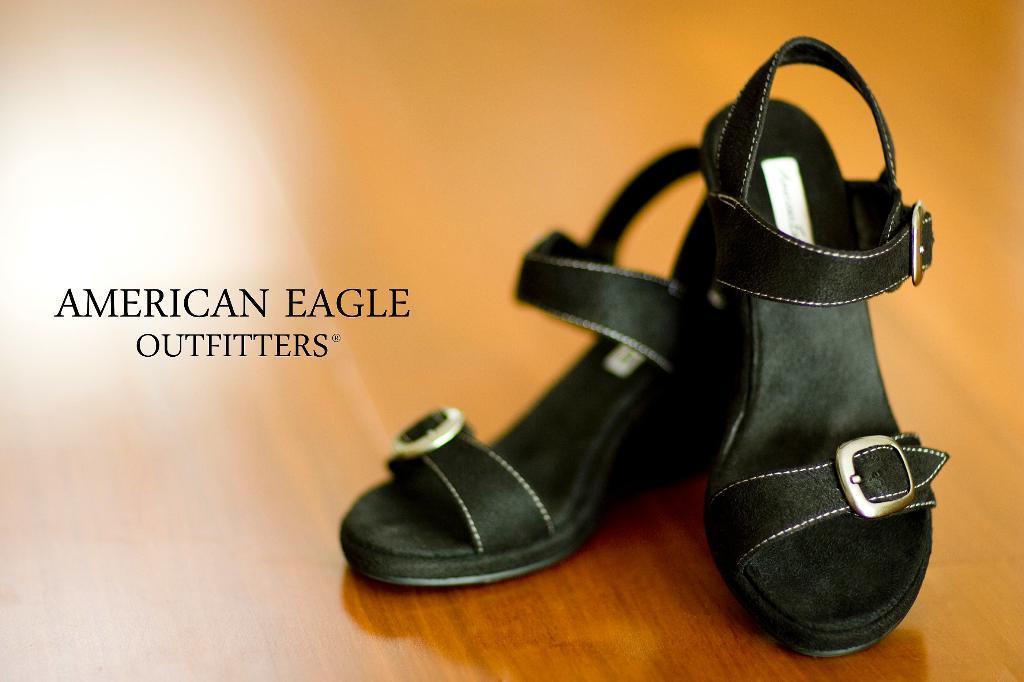Describe this image in one or two sentences. In this image I can see sandals in black color and the sandals are on the brown color surface and I can see something written on the image. 